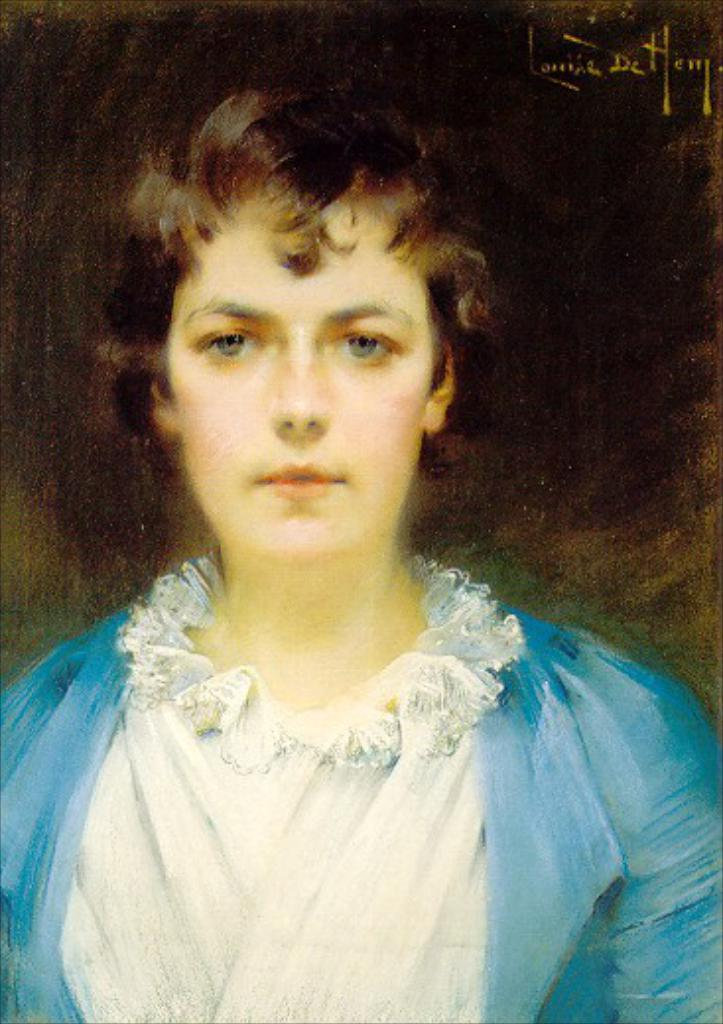What is depicted in the image? There is a painting of a woman in the image. What is the painting mounted on? The painting is on a board. What type of plants can be seen growing around the woman in the painting? There are no plants visible in the painting; it only depicts a woman. 